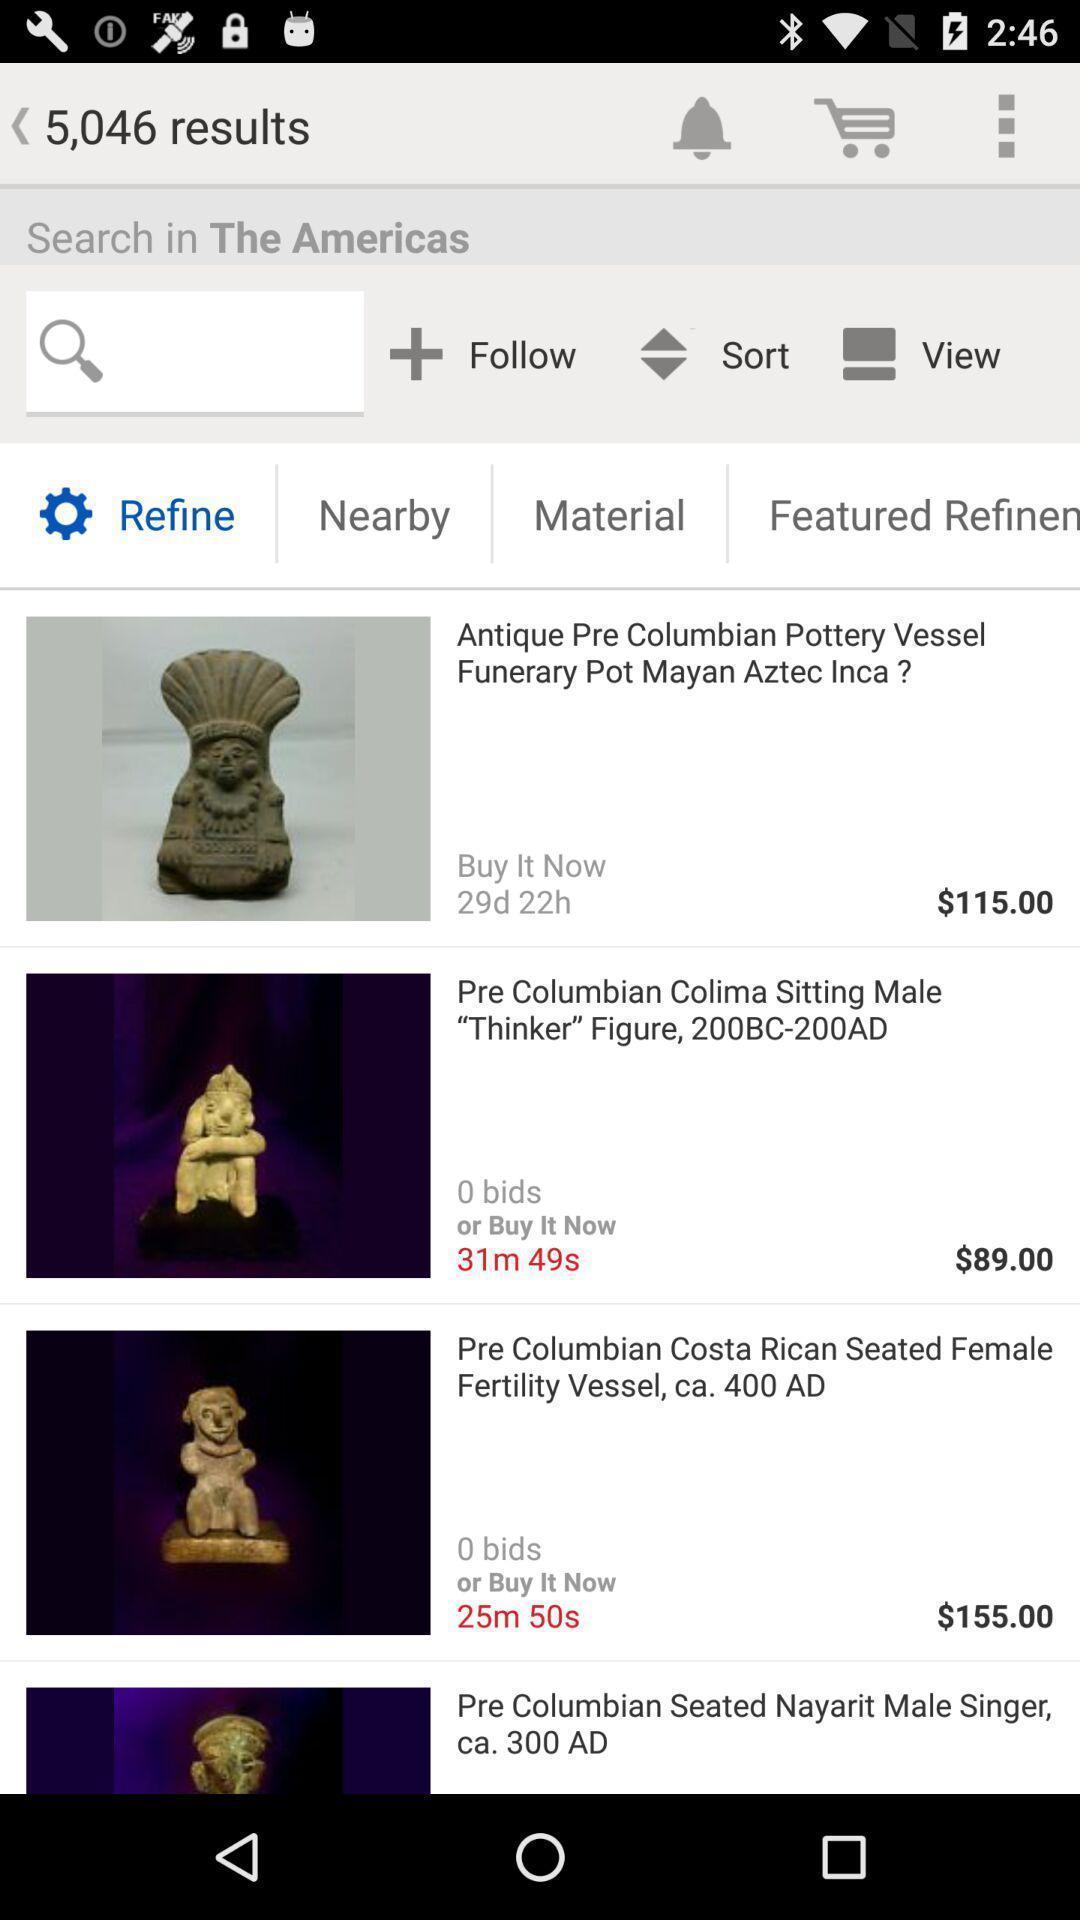Please provide a description for this image. Screen displaying multiple product images with price details. 